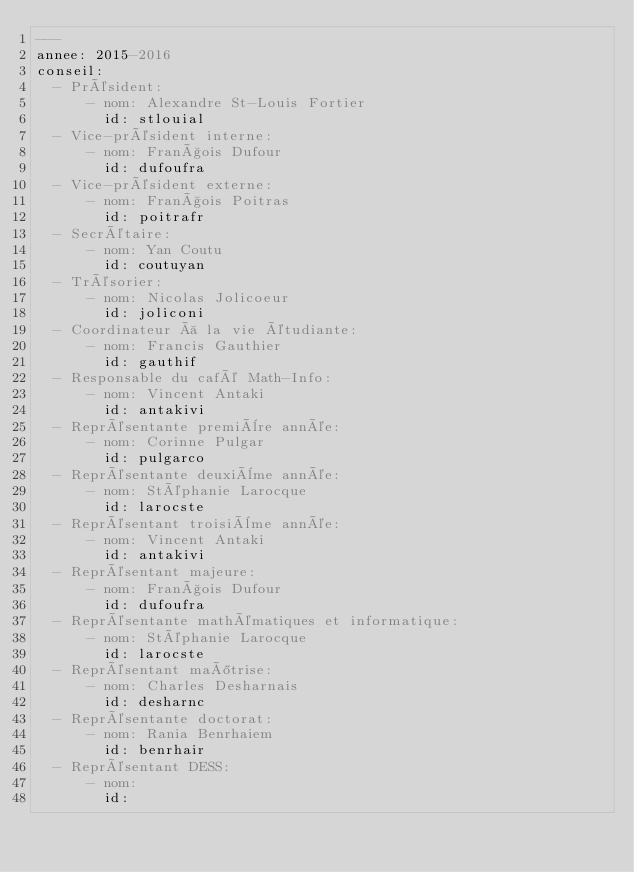<code> <loc_0><loc_0><loc_500><loc_500><_YAML_>---
annee: 2015-2016
conseil:
  - Président:
      - nom: Alexandre St-Louis Fortier
        id: stlouial
  - Vice-président interne:
      - nom: François Dufour
        id: dufoufra
  - Vice-président externe:
      - nom: François Poitras
        id: poitrafr
  - Secrétaire:
      - nom: Yan Coutu
        id: coutuyan
  - Trésorier:
      - nom: Nicolas Jolicoeur
        id: joliconi
  - Coordinateur à la vie étudiante:
      - nom: Francis Gauthier
        id: gauthif
  - Responsable du café Math-Info:
      - nom: Vincent Antaki
        id: antakivi
  - Représentante première année:
      - nom: Corinne Pulgar
        id: pulgarco
  - Représentante deuxième année:
      - nom: Stéphanie Larocque
        id: larocste
  - Représentant troisième année:
      - nom: Vincent Antaki
        id: antakivi
  - Représentant majeure:
      - nom: François Dufour
        id: dufoufra
  - Représentante mathématiques et informatique:
      - nom: Stéphanie Larocque
        id: larocste
  - Représentant maîtrise:
      - nom: Charles Desharnais
        id: desharnc
  - Représentante doctorat:
      - nom: Rania Benrhaiem
        id: benrhair
  - Représentant DESS:
      - nom:
        id:
</code> 